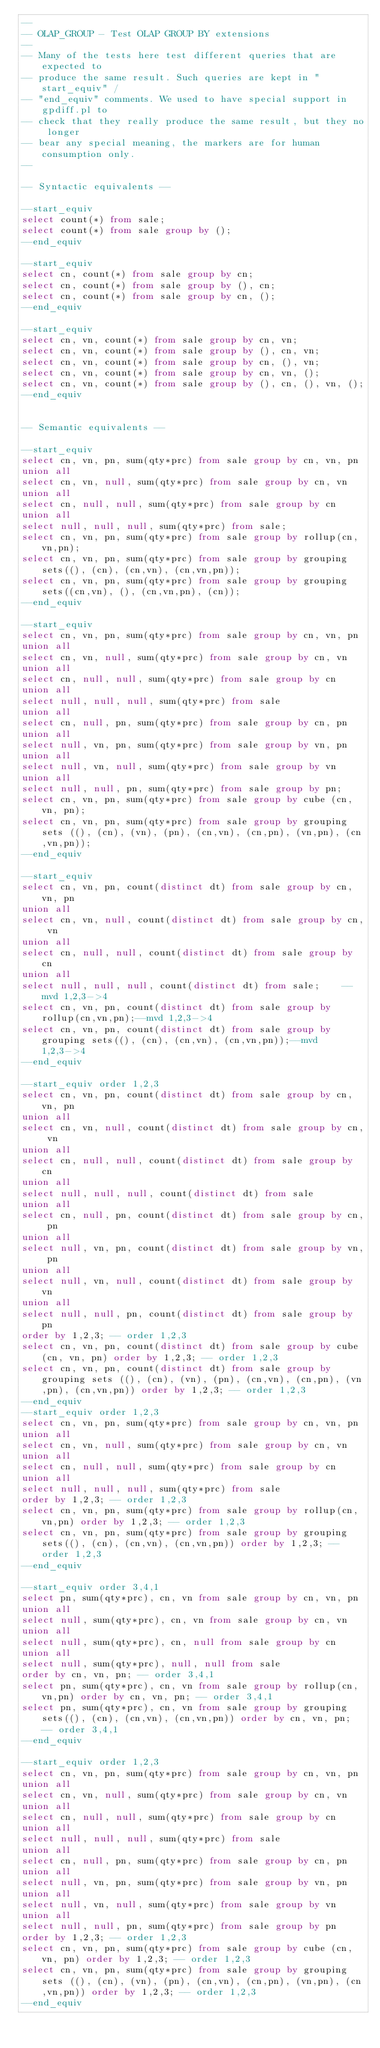<code> <loc_0><loc_0><loc_500><loc_500><_SQL_>--
-- OLAP_GROUP - Test OLAP GROUP BY extensions
--
-- Many of the tests here test different queries that are expected to
-- produce the same result. Such queries are kept in "start_equiv" /
-- "end_equiv" comments. We used to have special support in gpdiff.pl to
-- check that they really produce the same result, but they no longer
-- bear any special meaning, the markers are for human consumption only.
--

-- Syntactic equivalents --

--start_equiv
select count(*) from sale;
select count(*) from sale group by ();
--end_equiv

--start_equiv
select cn, count(*) from sale group by cn;
select cn, count(*) from sale group by (), cn;
select cn, count(*) from sale group by cn, ();
--end_equiv

--start_equiv
select cn, vn, count(*) from sale group by cn, vn;
select cn, vn, count(*) from sale group by (), cn, vn;
select cn, vn, count(*) from sale group by cn, (), vn;
select cn, vn, count(*) from sale group by cn, vn, ();
select cn, vn, count(*) from sale group by (), cn, (), vn, ();
--end_equiv


-- Semantic equivalents --

--start_equiv
select cn, vn, pn, sum(qty*prc) from sale group by cn, vn, pn
union all
select cn, vn, null, sum(qty*prc) from sale group by cn, vn
union all
select cn, null, null, sum(qty*prc) from sale group by cn
union all
select null, null, null, sum(qty*prc) from sale;    
select cn, vn, pn, sum(qty*prc) from sale group by rollup(cn,vn,pn);
select cn, vn, pn, sum(qty*prc) from sale group by grouping sets((), (cn), (cn,vn), (cn,vn,pn));
select cn, vn, pn, sum(qty*prc) from sale group by grouping sets((cn,vn), (), (cn,vn,pn), (cn));
--end_equiv

--start_equiv
select cn, vn, pn, sum(qty*prc) from sale group by cn, vn, pn
union all
select cn, vn, null, sum(qty*prc) from sale group by cn, vn
union all
select cn, null, null, sum(qty*prc) from sale group by cn
union all
select null, null, null, sum(qty*prc) from sale
union all
select cn, null, pn, sum(qty*prc) from sale group by cn, pn
union all
select null, vn, pn, sum(qty*prc) from sale group by vn, pn
union all
select null, vn, null, sum(qty*prc) from sale group by vn
union all
select null, null, pn, sum(qty*prc) from sale group by pn;
select cn, vn, pn, sum(qty*prc) from sale group by cube (cn, vn, pn);
select cn, vn, pn, sum(qty*prc) from sale group by grouping sets ((), (cn), (vn), (pn), (cn,vn), (cn,pn), (vn,pn), (cn,vn,pn));
--end_equiv

--start_equiv
select cn, vn, pn, count(distinct dt) from sale group by cn, vn, pn
union all
select cn, vn, null, count(distinct dt) from sale group by cn, vn
union all
select cn, null, null, count(distinct dt) from sale group by cn
union all
select null, null, null, count(distinct dt) from sale;    --mvd 1,2,3->4
select cn, vn, pn, count(distinct dt) from sale group by rollup(cn,vn,pn);--mvd 1,2,3->4
select cn, vn, pn, count(distinct dt) from sale group by grouping sets((), (cn), (cn,vn), (cn,vn,pn));--mvd 1,2,3->4
--end_equiv

--start_equiv order 1,2,3
select cn, vn, pn, count(distinct dt) from sale group by cn, vn, pn
union all
select cn, vn, null, count(distinct dt) from sale group by cn, vn
union all
select cn, null, null, count(distinct dt) from sale group by cn
union all
select null, null, null, count(distinct dt) from sale
union all
select cn, null, pn, count(distinct dt) from sale group by cn, pn
union all
select null, vn, pn, count(distinct dt) from sale group by vn, pn
union all
select null, vn, null, count(distinct dt) from sale group by vn
union all
select null, null, pn, count(distinct dt) from sale group by pn
order by 1,2,3; -- order 1,2,3
select cn, vn, pn, count(distinct dt) from sale group by cube (cn, vn, pn) order by 1,2,3; -- order 1,2,3
select cn, vn, pn, count(distinct dt) from sale group by grouping sets ((), (cn), (vn), (pn), (cn,vn), (cn,pn), (vn,pn), (cn,vn,pn)) order by 1,2,3; -- order 1,2,3
--end_equiv
--start_equiv order 1,2,3
select cn, vn, pn, sum(qty*prc) from sale group by cn, vn, pn
union all
select cn, vn, null, sum(qty*prc) from sale group by cn, vn
union all
select cn, null, null, sum(qty*prc) from sale group by cn
union all
select null, null, null, sum(qty*prc) from sale 
order by 1,2,3; -- order 1,2,3
select cn, vn, pn, sum(qty*prc) from sale group by rollup(cn,vn,pn) order by 1,2,3; -- order 1,2,3
select cn, vn, pn, sum(qty*prc) from sale group by grouping sets((), (cn), (cn,vn), (cn,vn,pn)) order by 1,2,3; -- order 1,2,3
--end_equiv

--start_equiv order 3,4,1
select pn, sum(qty*prc), cn, vn from sale group by cn, vn, pn
union all
select null, sum(qty*prc), cn, vn from sale group by cn, vn
union all
select null, sum(qty*prc), cn, null from sale group by cn
union all
select null, sum(qty*prc), null, null from sale 
order by cn, vn, pn; -- order 3,4,1
select pn, sum(qty*prc), cn, vn from sale group by rollup(cn,vn,pn) order by cn, vn, pn; -- order 3,4,1
select pn, sum(qty*prc), cn, vn from sale group by grouping sets((), (cn), (cn,vn), (cn,vn,pn)) order by cn, vn, pn; -- order 3,4,1
--end_equiv

--start_equiv order 1,2,3
select cn, vn, pn, sum(qty*prc) from sale group by cn, vn, pn
union all
select cn, vn, null, sum(qty*prc) from sale group by cn, vn
union all
select cn, null, null, sum(qty*prc) from sale group by cn
union all
select null, null, null, sum(qty*prc) from sale
union all
select cn, null, pn, sum(qty*prc) from sale group by cn, pn
union all
select null, vn, pn, sum(qty*prc) from sale group by vn, pn
union all
select null, vn, null, sum(qty*prc) from sale group by vn
union all
select null, null, pn, sum(qty*prc) from sale group by pn 
order by 1,2,3; -- order 1,2,3
select cn, vn, pn, sum(qty*prc) from sale group by cube (cn, vn, pn) order by 1,2,3; -- order 1,2,3
select cn, vn, pn, sum(qty*prc) from sale group by grouping sets ((), (cn), (vn), (pn), (cn,vn), (cn,pn), (vn,pn), (cn,vn,pn)) order by 1,2,3; -- order 1,2,3
--end_equiv
</code> 